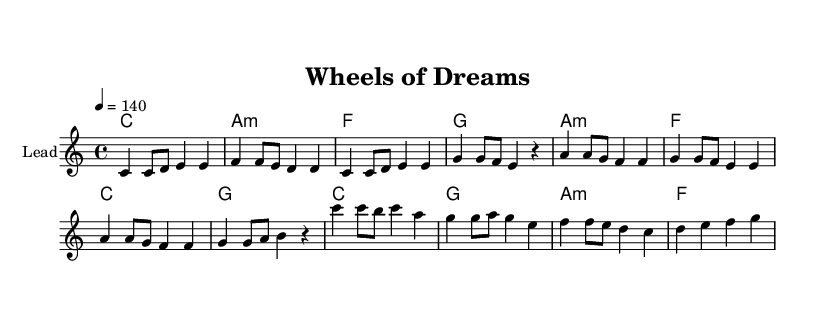What is the key signature of this music? The key signature is C major, which is indicated by having no sharps or flats next to the clef at the beginning of the staff.
Answer: C major What is the time signature of this music? The time signature is found right after the clef, shown as 4/4, which means there are 4 beats in each measure.
Answer: 4/4 What is the tempo marking of this piece? The tempo marking is indicated in the score as "4 = 140", meaning it is to be played at 140 beats per minute, measured by the quarter note.
Answer: 140 How many measures are there in the verse section? By counting the measures from the melody section labeled as "Verse" in the score, there are four measures total.
Answer: 4 In which section do you see the lyrics about "chasing neon, chasing lights"? These lyrics appear in the verse section as specified by the text following the stanza label "Verse:".
Answer: Verse What two chords start off the pre-chorus? The chords at the beginning of the pre-chorus section are indicated as A minor and F, which can be found in the harmonies section under the "Pre-Chorus" label.
Answer: A minor, F What is the final line of the chorus? The last line of the chorus can be found in the lyrics section labeled "Chorus" and is "Chasing dreams at a breakneck pace."
Answer: Chasing dreams at a breakneck pace 